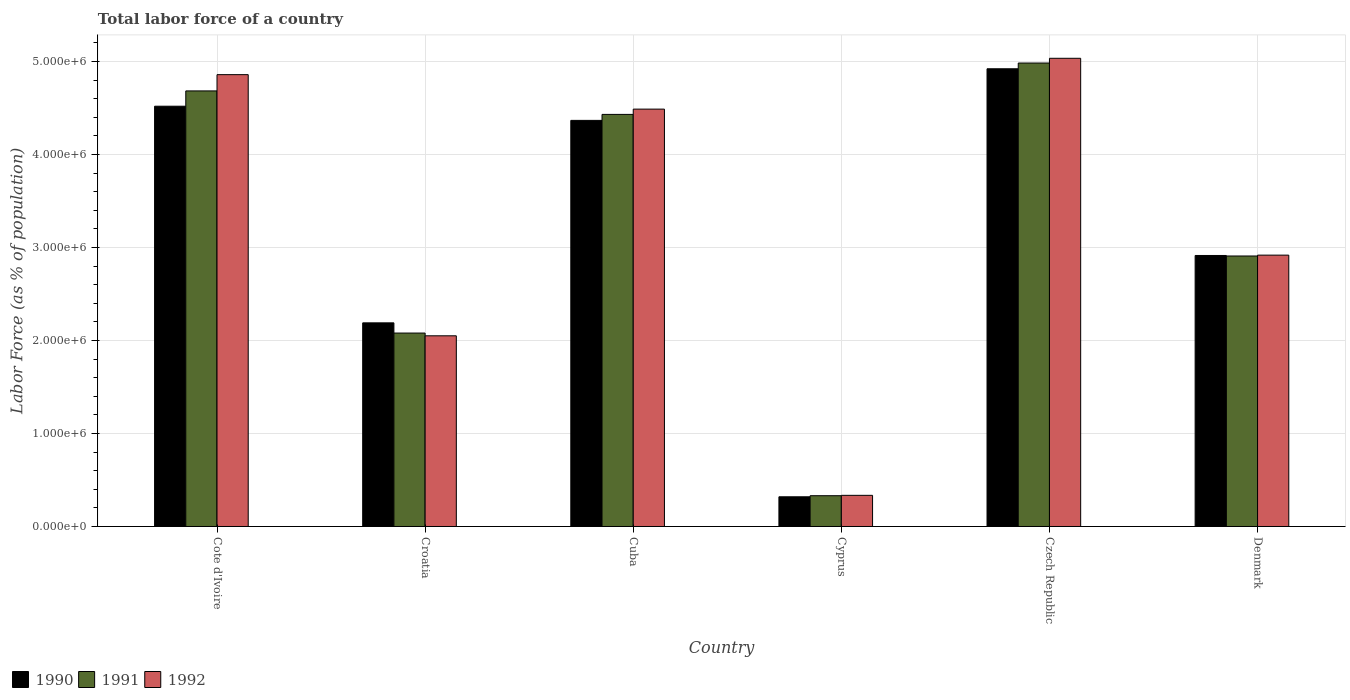How many groups of bars are there?
Give a very brief answer. 6. Are the number of bars per tick equal to the number of legend labels?
Your response must be concise. Yes. Are the number of bars on each tick of the X-axis equal?
Make the answer very short. Yes. How many bars are there on the 5th tick from the right?
Ensure brevity in your answer.  3. What is the label of the 3rd group of bars from the left?
Make the answer very short. Cuba. What is the percentage of labor force in 1990 in Cote d'Ivoire?
Ensure brevity in your answer.  4.52e+06. Across all countries, what is the maximum percentage of labor force in 1990?
Provide a succinct answer. 4.92e+06. Across all countries, what is the minimum percentage of labor force in 1991?
Give a very brief answer. 3.31e+05. In which country was the percentage of labor force in 1990 maximum?
Your response must be concise. Czech Republic. In which country was the percentage of labor force in 1991 minimum?
Ensure brevity in your answer.  Cyprus. What is the total percentage of labor force in 1990 in the graph?
Your answer should be compact. 1.92e+07. What is the difference between the percentage of labor force in 1990 in Cote d'Ivoire and that in Czech Republic?
Make the answer very short. -4.03e+05. What is the difference between the percentage of labor force in 1991 in Denmark and the percentage of labor force in 1990 in Cote d'Ivoire?
Keep it short and to the point. -1.61e+06. What is the average percentage of labor force in 1991 per country?
Keep it short and to the point. 3.24e+06. What is the difference between the percentage of labor force of/in 1990 and percentage of labor force of/in 1992 in Denmark?
Your answer should be compact. -3632. What is the ratio of the percentage of labor force in 1990 in Croatia to that in Cyprus?
Your response must be concise. 6.86. Is the difference between the percentage of labor force in 1990 in Cyprus and Denmark greater than the difference between the percentage of labor force in 1992 in Cyprus and Denmark?
Ensure brevity in your answer.  No. What is the difference between the highest and the second highest percentage of labor force in 1992?
Your answer should be compact. 5.47e+05. What is the difference between the highest and the lowest percentage of labor force in 1992?
Keep it short and to the point. 4.70e+06. Is the sum of the percentage of labor force in 1991 in Cote d'Ivoire and Croatia greater than the maximum percentage of labor force in 1990 across all countries?
Ensure brevity in your answer.  Yes. What does the 1st bar from the left in Croatia represents?
Your response must be concise. 1990. Is it the case that in every country, the sum of the percentage of labor force in 1992 and percentage of labor force in 1991 is greater than the percentage of labor force in 1990?
Provide a short and direct response. Yes. Are all the bars in the graph horizontal?
Ensure brevity in your answer.  No. Does the graph contain grids?
Provide a short and direct response. Yes. Where does the legend appear in the graph?
Ensure brevity in your answer.  Bottom left. How are the legend labels stacked?
Give a very brief answer. Horizontal. What is the title of the graph?
Make the answer very short. Total labor force of a country. What is the label or title of the Y-axis?
Offer a terse response. Labor Force (as % of population). What is the Labor Force (as % of population) of 1990 in Cote d'Ivoire?
Provide a short and direct response. 4.52e+06. What is the Labor Force (as % of population) of 1991 in Cote d'Ivoire?
Ensure brevity in your answer.  4.68e+06. What is the Labor Force (as % of population) in 1992 in Cote d'Ivoire?
Make the answer very short. 4.86e+06. What is the Labor Force (as % of population) in 1990 in Croatia?
Make the answer very short. 2.19e+06. What is the Labor Force (as % of population) of 1991 in Croatia?
Give a very brief answer. 2.08e+06. What is the Labor Force (as % of population) of 1992 in Croatia?
Your answer should be very brief. 2.05e+06. What is the Labor Force (as % of population) of 1990 in Cuba?
Provide a succinct answer. 4.37e+06. What is the Labor Force (as % of population) in 1991 in Cuba?
Keep it short and to the point. 4.43e+06. What is the Labor Force (as % of population) in 1992 in Cuba?
Ensure brevity in your answer.  4.49e+06. What is the Labor Force (as % of population) in 1990 in Cyprus?
Your answer should be very brief. 3.19e+05. What is the Labor Force (as % of population) of 1991 in Cyprus?
Your answer should be compact. 3.31e+05. What is the Labor Force (as % of population) of 1992 in Cyprus?
Give a very brief answer. 3.35e+05. What is the Labor Force (as % of population) of 1990 in Czech Republic?
Provide a succinct answer. 4.92e+06. What is the Labor Force (as % of population) of 1991 in Czech Republic?
Your answer should be compact. 4.98e+06. What is the Labor Force (as % of population) in 1992 in Czech Republic?
Offer a very short reply. 5.03e+06. What is the Labor Force (as % of population) of 1990 in Denmark?
Ensure brevity in your answer.  2.91e+06. What is the Labor Force (as % of population) of 1991 in Denmark?
Ensure brevity in your answer.  2.91e+06. What is the Labor Force (as % of population) in 1992 in Denmark?
Ensure brevity in your answer.  2.92e+06. Across all countries, what is the maximum Labor Force (as % of population) of 1990?
Offer a terse response. 4.92e+06. Across all countries, what is the maximum Labor Force (as % of population) of 1991?
Your response must be concise. 4.98e+06. Across all countries, what is the maximum Labor Force (as % of population) in 1992?
Ensure brevity in your answer.  5.03e+06. Across all countries, what is the minimum Labor Force (as % of population) in 1990?
Provide a succinct answer. 3.19e+05. Across all countries, what is the minimum Labor Force (as % of population) in 1991?
Give a very brief answer. 3.31e+05. Across all countries, what is the minimum Labor Force (as % of population) in 1992?
Provide a succinct answer. 3.35e+05. What is the total Labor Force (as % of population) in 1990 in the graph?
Your answer should be compact. 1.92e+07. What is the total Labor Force (as % of population) of 1991 in the graph?
Make the answer very short. 1.94e+07. What is the total Labor Force (as % of population) in 1992 in the graph?
Your answer should be compact. 1.97e+07. What is the difference between the Labor Force (as % of population) in 1990 in Cote d'Ivoire and that in Croatia?
Provide a succinct answer. 2.33e+06. What is the difference between the Labor Force (as % of population) of 1991 in Cote d'Ivoire and that in Croatia?
Offer a very short reply. 2.60e+06. What is the difference between the Labor Force (as % of population) in 1992 in Cote d'Ivoire and that in Croatia?
Keep it short and to the point. 2.81e+06. What is the difference between the Labor Force (as % of population) of 1990 in Cote d'Ivoire and that in Cuba?
Provide a short and direct response. 1.52e+05. What is the difference between the Labor Force (as % of population) in 1991 in Cote d'Ivoire and that in Cuba?
Keep it short and to the point. 2.53e+05. What is the difference between the Labor Force (as % of population) in 1992 in Cote d'Ivoire and that in Cuba?
Provide a succinct answer. 3.71e+05. What is the difference between the Labor Force (as % of population) of 1990 in Cote d'Ivoire and that in Cyprus?
Your answer should be compact. 4.20e+06. What is the difference between the Labor Force (as % of population) of 1991 in Cote d'Ivoire and that in Cyprus?
Provide a succinct answer. 4.35e+06. What is the difference between the Labor Force (as % of population) of 1992 in Cote d'Ivoire and that in Cyprus?
Give a very brief answer. 4.52e+06. What is the difference between the Labor Force (as % of population) of 1990 in Cote d'Ivoire and that in Czech Republic?
Your answer should be very brief. -4.03e+05. What is the difference between the Labor Force (as % of population) of 1991 in Cote d'Ivoire and that in Czech Republic?
Offer a terse response. -3.00e+05. What is the difference between the Labor Force (as % of population) of 1992 in Cote d'Ivoire and that in Czech Republic?
Give a very brief answer. -1.76e+05. What is the difference between the Labor Force (as % of population) of 1990 in Cote d'Ivoire and that in Denmark?
Your response must be concise. 1.60e+06. What is the difference between the Labor Force (as % of population) of 1991 in Cote d'Ivoire and that in Denmark?
Give a very brief answer. 1.77e+06. What is the difference between the Labor Force (as % of population) in 1992 in Cote d'Ivoire and that in Denmark?
Provide a short and direct response. 1.94e+06. What is the difference between the Labor Force (as % of population) of 1990 in Croatia and that in Cuba?
Keep it short and to the point. -2.18e+06. What is the difference between the Labor Force (as % of population) of 1991 in Croatia and that in Cuba?
Ensure brevity in your answer.  -2.35e+06. What is the difference between the Labor Force (as % of population) of 1992 in Croatia and that in Cuba?
Give a very brief answer. -2.44e+06. What is the difference between the Labor Force (as % of population) in 1990 in Croatia and that in Cyprus?
Keep it short and to the point. 1.87e+06. What is the difference between the Labor Force (as % of population) in 1991 in Croatia and that in Cyprus?
Provide a short and direct response. 1.75e+06. What is the difference between the Labor Force (as % of population) in 1992 in Croatia and that in Cyprus?
Keep it short and to the point. 1.72e+06. What is the difference between the Labor Force (as % of population) in 1990 in Croatia and that in Czech Republic?
Make the answer very short. -2.73e+06. What is the difference between the Labor Force (as % of population) in 1991 in Croatia and that in Czech Republic?
Provide a succinct answer. -2.90e+06. What is the difference between the Labor Force (as % of population) of 1992 in Croatia and that in Czech Republic?
Make the answer very short. -2.98e+06. What is the difference between the Labor Force (as % of population) in 1990 in Croatia and that in Denmark?
Your answer should be very brief. -7.24e+05. What is the difference between the Labor Force (as % of population) in 1991 in Croatia and that in Denmark?
Offer a very short reply. -8.28e+05. What is the difference between the Labor Force (as % of population) of 1992 in Croatia and that in Denmark?
Provide a succinct answer. -8.67e+05. What is the difference between the Labor Force (as % of population) in 1990 in Cuba and that in Cyprus?
Your response must be concise. 4.05e+06. What is the difference between the Labor Force (as % of population) in 1991 in Cuba and that in Cyprus?
Your response must be concise. 4.10e+06. What is the difference between the Labor Force (as % of population) in 1992 in Cuba and that in Cyprus?
Your answer should be compact. 4.15e+06. What is the difference between the Labor Force (as % of population) in 1990 in Cuba and that in Czech Republic?
Your response must be concise. -5.55e+05. What is the difference between the Labor Force (as % of population) in 1991 in Cuba and that in Czech Republic?
Keep it short and to the point. -5.52e+05. What is the difference between the Labor Force (as % of population) in 1992 in Cuba and that in Czech Republic?
Keep it short and to the point. -5.47e+05. What is the difference between the Labor Force (as % of population) in 1990 in Cuba and that in Denmark?
Provide a succinct answer. 1.45e+06. What is the difference between the Labor Force (as % of population) of 1991 in Cuba and that in Denmark?
Offer a terse response. 1.52e+06. What is the difference between the Labor Force (as % of population) of 1992 in Cuba and that in Denmark?
Your answer should be very brief. 1.57e+06. What is the difference between the Labor Force (as % of population) in 1990 in Cyprus and that in Czech Republic?
Your answer should be very brief. -4.60e+06. What is the difference between the Labor Force (as % of population) of 1991 in Cyprus and that in Czech Republic?
Your answer should be compact. -4.65e+06. What is the difference between the Labor Force (as % of population) of 1992 in Cyprus and that in Czech Republic?
Your response must be concise. -4.70e+06. What is the difference between the Labor Force (as % of population) of 1990 in Cyprus and that in Denmark?
Make the answer very short. -2.59e+06. What is the difference between the Labor Force (as % of population) of 1991 in Cyprus and that in Denmark?
Keep it short and to the point. -2.58e+06. What is the difference between the Labor Force (as % of population) of 1992 in Cyprus and that in Denmark?
Offer a very short reply. -2.58e+06. What is the difference between the Labor Force (as % of population) in 1990 in Czech Republic and that in Denmark?
Your answer should be very brief. 2.01e+06. What is the difference between the Labor Force (as % of population) of 1991 in Czech Republic and that in Denmark?
Your answer should be very brief. 2.07e+06. What is the difference between the Labor Force (as % of population) in 1992 in Czech Republic and that in Denmark?
Give a very brief answer. 2.12e+06. What is the difference between the Labor Force (as % of population) in 1990 in Cote d'Ivoire and the Labor Force (as % of population) in 1991 in Croatia?
Your response must be concise. 2.44e+06. What is the difference between the Labor Force (as % of population) in 1990 in Cote d'Ivoire and the Labor Force (as % of population) in 1992 in Croatia?
Give a very brief answer. 2.47e+06. What is the difference between the Labor Force (as % of population) of 1991 in Cote d'Ivoire and the Labor Force (as % of population) of 1992 in Croatia?
Provide a succinct answer. 2.63e+06. What is the difference between the Labor Force (as % of population) in 1990 in Cote d'Ivoire and the Labor Force (as % of population) in 1991 in Cuba?
Provide a short and direct response. 8.79e+04. What is the difference between the Labor Force (as % of population) of 1990 in Cote d'Ivoire and the Labor Force (as % of population) of 1992 in Cuba?
Keep it short and to the point. 3.12e+04. What is the difference between the Labor Force (as % of population) in 1991 in Cote d'Ivoire and the Labor Force (as % of population) in 1992 in Cuba?
Give a very brief answer. 1.96e+05. What is the difference between the Labor Force (as % of population) in 1990 in Cote d'Ivoire and the Labor Force (as % of population) in 1991 in Cyprus?
Your response must be concise. 4.19e+06. What is the difference between the Labor Force (as % of population) of 1990 in Cote d'Ivoire and the Labor Force (as % of population) of 1992 in Cyprus?
Keep it short and to the point. 4.18e+06. What is the difference between the Labor Force (as % of population) in 1991 in Cote d'Ivoire and the Labor Force (as % of population) in 1992 in Cyprus?
Your answer should be very brief. 4.35e+06. What is the difference between the Labor Force (as % of population) in 1990 in Cote d'Ivoire and the Labor Force (as % of population) in 1991 in Czech Republic?
Keep it short and to the point. -4.64e+05. What is the difference between the Labor Force (as % of population) of 1990 in Cote d'Ivoire and the Labor Force (as % of population) of 1992 in Czech Republic?
Your answer should be compact. -5.15e+05. What is the difference between the Labor Force (as % of population) of 1991 in Cote d'Ivoire and the Labor Force (as % of population) of 1992 in Czech Republic?
Offer a very short reply. -3.51e+05. What is the difference between the Labor Force (as % of population) in 1990 in Cote d'Ivoire and the Labor Force (as % of population) in 1991 in Denmark?
Your response must be concise. 1.61e+06. What is the difference between the Labor Force (as % of population) of 1990 in Cote d'Ivoire and the Labor Force (as % of population) of 1992 in Denmark?
Offer a terse response. 1.60e+06. What is the difference between the Labor Force (as % of population) of 1991 in Cote d'Ivoire and the Labor Force (as % of population) of 1992 in Denmark?
Ensure brevity in your answer.  1.77e+06. What is the difference between the Labor Force (as % of population) in 1990 in Croatia and the Labor Force (as % of population) in 1991 in Cuba?
Offer a very short reply. -2.24e+06. What is the difference between the Labor Force (as % of population) in 1990 in Croatia and the Labor Force (as % of population) in 1992 in Cuba?
Provide a succinct answer. -2.30e+06. What is the difference between the Labor Force (as % of population) in 1991 in Croatia and the Labor Force (as % of population) in 1992 in Cuba?
Your answer should be compact. -2.41e+06. What is the difference between the Labor Force (as % of population) in 1990 in Croatia and the Labor Force (as % of population) in 1991 in Cyprus?
Your response must be concise. 1.86e+06. What is the difference between the Labor Force (as % of population) in 1990 in Croatia and the Labor Force (as % of population) in 1992 in Cyprus?
Your answer should be very brief. 1.85e+06. What is the difference between the Labor Force (as % of population) of 1991 in Croatia and the Labor Force (as % of population) of 1992 in Cyprus?
Ensure brevity in your answer.  1.74e+06. What is the difference between the Labor Force (as % of population) of 1990 in Croatia and the Labor Force (as % of population) of 1991 in Czech Republic?
Your response must be concise. -2.79e+06. What is the difference between the Labor Force (as % of population) of 1990 in Croatia and the Labor Force (as % of population) of 1992 in Czech Republic?
Provide a short and direct response. -2.84e+06. What is the difference between the Labor Force (as % of population) of 1991 in Croatia and the Labor Force (as % of population) of 1992 in Czech Republic?
Make the answer very short. -2.95e+06. What is the difference between the Labor Force (as % of population) of 1990 in Croatia and the Labor Force (as % of population) of 1991 in Denmark?
Offer a terse response. -7.19e+05. What is the difference between the Labor Force (as % of population) in 1990 in Croatia and the Labor Force (as % of population) in 1992 in Denmark?
Offer a terse response. -7.28e+05. What is the difference between the Labor Force (as % of population) of 1991 in Croatia and the Labor Force (as % of population) of 1992 in Denmark?
Offer a very short reply. -8.38e+05. What is the difference between the Labor Force (as % of population) in 1990 in Cuba and the Labor Force (as % of population) in 1991 in Cyprus?
Offer a terse response. 4.04e+06. What is the difference between the Labor Force (as % of population) in 1990 in Cuba and the Labor Force (as % of population) in 1992 in Cyprus?
Make the answer very short. 4.03e+06. What is the difference between the Labor Force (as % of population) of 1991 in Cuba and the Labor Force (as % of population) of 1992 in Cyprus?
Keep it short and to the point. 4.10e+06. What is the difference between the Labor Force (as % of population) in 1990 in Cuba and the Labor Force (as % of population) in 1991 in Czech Republic?
Ensure brevity in your answer.  -6.17e+05. What is the difference between the Labor Force (as % of population) of 1990 in Cuba and the Labor Force (as % of population) of 1992 in Czech Republic?
Offer a terse response. -6.68e+05. What is the difference between the Labor Force (as % of population) in 1991 in Cuba and the Labor Force (as % of population) in 1992 in Czech Republic?
Ensure brevity in your answer.  -6.03e+05. What is the difference between the Labor Force (as % of population) of 1990 in Cuba and the Labor Force (as % of population) of 1991 in Denmark?
Give a very brief answer. 1.46e+06. What is the difference between the Labor Force (as % of population) in 1990 in Cuba and the Labor Force (as % of population) in 1992 in Denmark?
Give a very brief answer. 1.45e+06. What is the difference between the Labor Force (as % of population) of 1991 in Cuba and the Labor Force (as % of population) of 1992 in Denmark?
Your answer should be very brief. 1.51e+06. What is the difference between the Labor Force (as % of population) in 1990 in Cyprus and the Labor Force (as % of population) in 1991 in Czech Republic?
Make the answer very short. -4.66e+06. What is the difference between the Labor Force (as % of population) in 1990 in Cyprus and the Labor Force (as % of population) in 1992 in Czech Republic?
Your response must be concise. -4.71e+06. What is the difference between the Labor Force (as % of population) of 1991 in Cyprus and the Labor Force (as % of population) of 1992 in Czech Republic?
Provide a succinct answer. -4.70e+06. What is the difference between the Labor Force (as % of population) of 1990 in Cyprus and the Labor Force (as % of population) of 1991 in Denmark?
Offer a terse response. -2.59e+06. What is the difference between the Labor Force (as % of population) of 1990 in Cyprus and the Labor Force (as % of population) of 1992 in Denmark?
Provide a succinct answer. -2.60e+06. What is the difference between the Labor Force (as % of population) in 1991 in Cyprus and the Labor Force (as % of population) in 1992 in Denmark?
Your answer should be very brief. -2.59e+06. What is the difference between the Labor Force (as % of population) in 1990 in Czech Republic and the Labor Force (as % of population) in 1991 in Denmark?
Provide a short and direct response. 2.01e+06. What is the difference between the Labor Force (as % of population) in 1990 in Czech Republic and the Labor Force (as % of population) in 1992 in Denmark?
Provide a succinct answer. 2.00e+06. What is the difference between the Labor Force (as % of population) in 1991 in Czech Republic and the Labor Force (as % of population) in 1992 in Denmark?
Your answer should be very brief. 2.07e+06. What is the average Labor Force (as % of population) in 1990 per country?
Offer a terse response. 3.20e+06. What is the average Labor Force (as % of population) in 1991 per country?
Provide a succinct answer. 3.24e+06. What is the average Labor Force (as % of population) in 1992 per country?
Provide a short and direct response. 3.28e+06. What is the difference between the Labor Force (as % of population) of 1990 and Labor Force (as % of population) of 1991 in Cote d'Ivoire?
Your response must be concise. -1.65e+05. What is the difference between the Labor Force (as % of population) of 1990 and Labor Force (as % of population) of 1992 in Cote d'Ivoire?
Give a very brief answer. -3.39e+05. What is the difference between the Labor Force (as % of population) of 1991 and Labor Force (as % of population) of 1992 in Cote d'Ivoire?
Your answer should be compact. -1.75e+05. What is the difference between the Labor Force (as % of population) in 1990 and Labor Force (as % of population) in 1991 in Croatia?
Your answer should be compact. 1.10e+05. What is the difference between the Labor Force (as % of population) in 1990 and Labor Force (as % of population) in 1992 in Croatia?
Provide a short and direct response. 1.39e+05. What is the difference between the Labor Force (as % of population) of 1991 and Labor Force (as % of population) of 1992 in Croatia?
Your answer should be compact. 2.97e+04. What is the difference between the Labor Force (as % of population) of 1990 and Labor Force (as % of population) of 1991 in Cuba?
Your answer should be very brief. -6.43e+04. What is the difference between the Labor Force (as % of population) in 1990 and Labor Force (as % of population) in 1992 in Cuba?
Offer a terse response. -1.21e+05. What is the difference between the Labor Force (as % of population) in 1991 and Labor Force (as % of population) in 1992 in Cuba?
Your response must be concise. -5.67e+04. What is the difference between the Labor Force (as % of population) of 1990 and Labor Force (as % of population) of 1991 in Cyprus?
Keep it short and to the point. -1.16e+04. What is the difference between the Labor Force (as % of population) in 1990 and Labor Force (as % of population) in 1992 in Cyprus?
Ensure brevity in your answer.  -1.55e+04. What is the difference between the Labor Force (as % of population) in 1991 and Labor Force (as % of population) in 1992 in Cyprus?
Ensure brevity in your answer.  -3948. What is the difference between the Labor Force (as % of population) in 1990 and Labor Force (as % of population) in 1991 in Czech Republic?
Offer a terse response. -6.18e+04. What is the difference between the Labor Force (as % of population) of 1990 and Labor Force (as % of population) of 1992 in Czech Republic?
Make the answer very short. -1.13e+05. What is the difference between the Labor Force (as % of population) of 1991 and Labor Force (as % of population) of 1992 in Czech Republic?
Your answer should be very brief. -5.09e+04. What is the difference between the Labor Force (as % of population) of 1990 and Labor Force (as % of population) of 1991 in Denmark?
Keep it short and to the point. 5525. What is the difference between the Labor Force (as % of population) of 1990 and Labor Force (as % of population) of 1992 in Denmark?
Your response must be concise. -3632. What is the difference between the Labor Force (as % of population) in 1991 and Labor Force (as % of population) in 1992 in Denmark?
Your response must be concise. -9157. What is the ratio of the Labor Force (as % of population) of 1990 in Cote d'Ivoire to that in Croatia?
Ensure brevity in your answer.  2.06. What is the ratio of the Labor Force (as % of population) in 1991 in Cote d'Ivoire to that in Croatia?
Offer a terse response. 2.25. What is the ratio of the Labor Force (as % of population) in 1992 in Cote d'Ivoire to that in Croatia?
Offer a terse response. 2.37. What is the ratio of the Labor Force (as % of population) of 1990 in Cote d'Ivoire to that in Cuba?
Offer a terse response. 1.03. What is the ratio of the Labor Force (as % of population) in 1991 in Cote d'Ivoire to that in Cuba?
Ensure brevity in your answer.  1.06. What is the ratio of the Labor Force (as % of population) of 1992 in Cote d'Ivoire to that in Cuba?
Your answer should be very brief. 1.08. What is the ratio of the Labor Force (as % of population) in 1990 in Cote d'Ivoire to that in Cyprus?
Your answer should be compact. 14.15. What is the ratio of the Labor Force (as % of population) of 1991 in Cote d'Ivoire to that in Cyprus?
Make the answer very short. 14.15. What is the ratio of the Labor Force (as % of population) in 1992 in Cote d'Ivoire to that in Cyprus?
Your answer should be very brief. 14.51. What is the ratio of the Labor Force (as % of population) of 1990 in Cote d'Ivoire to that in Czech Republic?
Your response must be concise. 0.92. What is the ratio of the Labor Force (as % of population) in 1991 in Cote d'Ivoire to that in Czech Republic?
Your response must be concise. 0.94. What is the ratio of the Labor Force (as % of population) of 1992 in Cote d'Ivoire to that in Czech Republic?
Make the answer very short. 0.97. What is the ratio of the Labor Force (as % of population) of 1990 in Cote d'Ivoire to that in Denmark?
Keep it short and to the point. 1.55. What is the ratio of the Labor Force (as % of population) of 1991 in Cote d'Ivoire to that in Denmark?
Your answer should be very brief. 1.61. What is the ratio of the Labor Force (as % of population) of 1992 in Cote d'Ivoire to that in Denmark?
Your answer should be compact. 1.67. What is the ratio of the Labor Force (as % of population) in 1990 in Croatia to that in Cuba?
Give a very brief answer. 0.5. What is the ratio of the Labor Force (as % of population) of 1991 in Croatia to that in Cuba?
Give a very brief answer. 0.47. What is the ratio of the Labor Force (as % of population) of 1992 in Croatia to that in Cuba?
Your answer should be compact. 0.46. What is the ratio of the Labor Force (as % of population) of 1990 in Croatia to that in Cyprus?
Keep it short and to the point. 6.86. What is the ratio of the Labor Force (as % of population) of 1991 in Croatia to that in Cyprus?
Ensure brevity in your answer.  6.29. What is the ratio of the Labor Force (as % of population) in 1992 in Croatia to that in Cyprus?
Your response must be concise. 6.12. What is the ratio of the Labor Force (as % of population) of 1990 in Croatia to that in Czech Republic?
Provide a short and direct response. 0.44. What is the ratio of the Labor Force (as % of population) in 1991 in Croatia to that in Czech Republic?
Your answer should be very brief. 0.42. What is the ratio of the Labor Force (as % of population) of 1992 in Croatia to that in Czech Republic?
Offer a terse response. 0.41. What is the ratio of the Labor Force (as % of population) in 1990 in Croatia to that in Denmark?
Keep it short and to the point. 0.75. What is the ratio of the Labor Force (as % of population) of 1991 in Croatia to that in Denmark?
Provide a succinct answer. 0.72. What is the ratio of the Labor Force (as % of population) of 1992 in Croatia to that in Denmark?
Your answer should be compact. 0.7. What is the ratio of the Labor Force (as % of population) of 1990 in Cuba to that in Cyprus?
Provide a succinct answer. 13.67. What is the ratio of the Labor Force (as % of population) in 1991 in Cuba to that in Cyprus?
Make the answer very short. 13.39. What is the ratio of the Labor Force (as % of population) in 1992 in Cuba to that in Cyprus?
Your answer should be very brief. 13.4. What is the ratio of the Labor Force (as % of population) in 1990 in Cuba to that in Czech Republic?
Provide a succinct answer. 0.89. What is the ratio of the Labor Force (as % of population) in 1991 in Cuba to that in Czech Republic?
Your answer should be compact. 0.89. What is the ratio of the Labor Force (as % of population) of 1992 in Cuba to that in Czech Republic?
Keep it short and to the point. 0.89. What is the ratio of the Labor Force (as % of population) in 1990 in Cuba to that in Denmark?
Your answer should be compact. 1.5. What is the ratio of the Labor Force (as % of population) in 1991 in Cuba to that in Denmark?
Offer a very short reply. 1.52. What is the ratio of the Labor Force (as % of population) of 1992 in Cuba to that in Denmark?
Provide a short and direct response. 1.54. What is the ratio of the Labor Force (as % of population) of 1990 in Cyprus to that in Czech Republic?
Keep it short and to the point. 0.06. What is the ratio of the Labor Force (as % of population) of 1991 in Cyprus to that in Czech Republic?
Ensure brevity in your answer.  0.07. What is the ratio of the Labor Force (as % of population) in 1992 in Cyprus to that in Czech Republic?
Your answer should be very brief. 0.07. What is the ratio of the Labor Force (as % of population) of 1990 in Cyprus to that in Denmark?
Ensure brevity in your answer.  0.11. What is the ratio of the Labor Force (as % of population) of 1991 in Cyprus to that in Denmark?
Provide a short and direct response. 0.11. What is the ratio of the Labor Force (as % of population) of 1992 in Cyprus to that in Denmark?
Offer a terse response. 0.11. What is the ratio of the Labor Force (as % of population) in 1990 in Czech Republic to that in Denmark?
Provide a short and direct response. 1.69. What is the ratio of the Labor Force (as % of population) of 1991 in Czech Republic to that in Denmark?
Make the answer very short. 1.71. What is the ratio of the Labor Force (as % of population) of 1992 in Czech Republic to that in Denmark?
Offer a very short reply. 1.73. What is the difference between the highest and the second highest Labor Force (as % of population) in 1990?
Give a very brief answer. 4.03e+05. What is the difference between the highest and the second highest Labor Force (as % of population) of 1991?
Your answer should be very brief. 3.00e+05. What is the difference between the highest and the second highest Labor Force (as % of population) of 1992?
Provide a succinct answer. 1.76e+05. What is the difference between the highest and the lowest Labor Force (as % of population) of 1990?
Make the answer very short. 4.60e+06. What is the difference between the highest and the lowest Labor Force (as % of population) of 1991?
Provide a short and direct response. 4.65e+06. What is the difference between the highest and the lowest Labor Force (as % of population) in 1992?
Provide a succinct answer. 4.70e+06. 